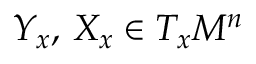Convert formula to latex. <formula><loc_0><loc_0><loc_500><loc_500>Y _ { x } , \, X _ { x } \in T _ { x } M ^ { n }</formula> 